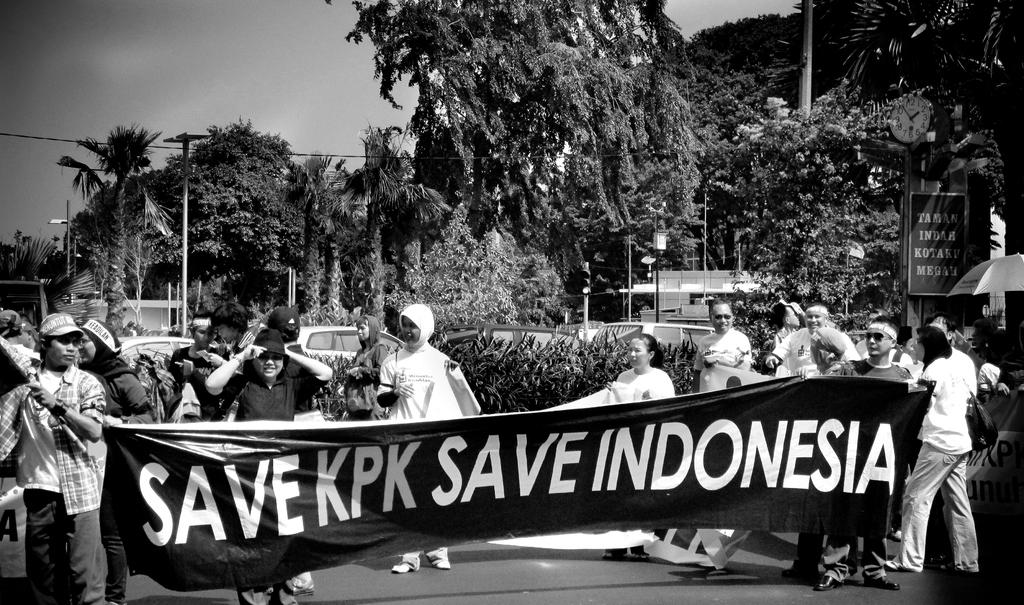What types of living organisms can be seen in the image? People and plants are visible in the image. What else can be seen in the image besides living organisms? Vehicles, a banner, trees, a clock, a flag, and light poles are also visible in the image. What type of texture can be seen on the branch of the tree in the image? There is no branch visible in the image, as it only shows trees in the background. 